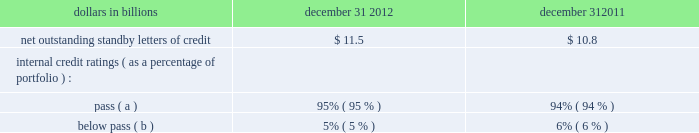Table 153 : net outstanding standby letters of credit dollars in billions december 31 december 31 .
( a ) indicates that expected risk of loss is currently low .
( b ) indicates a higher degree of risk of default .
If the customer fails to meet its financial or performance obligation to the third party under the terms of the contract or there is a need to support a remarketing program , then upon the request of the guaranteed party , subject to the terms of the letter of credit , we would be obligated to make payment to them .
The standby letters of credit and risk participations in standby letters of credit and bankers 2019 acceptances outstanding on december 31 , 2012 had terms ranging from less than 1 year to 7 years .
The aggregate maximum amount of future payments pnc could be required to make under outstanding standby letters of credit and risk participations in standby letters of credit and bankers 2019 acceptances was $ 14.7 billion at december 31 , 2012 , of which $ 7.5 billion support remarketing programs .
As of december 31 , 2012 , assets of $ 1.8 billion secured certain specifically identified standby letters of credit .
Recourse provisions from third parties of $ 3.2 billion were also available for this purpose as of december 31 , 2012 .
In addition , a portion of the remaining standby letters of credit and letter of credit risk participations issued on behalf of specific customers is also secured by collateral or guarantees that secure the customers 2019 other obligations to us .
The carrying amount of the liability for our obligations related to standby letters of credit and risk participations in standby letters of credit and bankers 2019 acceptances was $ 247 million at december 31 , 2012 .
Standby bond purchase agreements and other liquidity facilities we enter into standby bond purchase agreements to support municipal bond obligations .
At december 31 , 2012 , the aggregate of our commitments under these facilities was $ 587 million .
We also enter into certain other liquidity facilities to support individual pools of receivables acquired by commercial paper conduits .
At december 31 , 2012 , our total commitments under these facilities were $ 145 million .
Indemnifications we are a party to numerous acquisition or divestiture agreements under which we have purchased or sold , or agreed to purchase or sell , various types of assets .
These agreements can cover the purchase or sale of : 2022 entire businesses , 2022 loan portfolios , 2022 branch banks , 2022 partial interests in companies , or 2022 other types of assets .
These agreements generally include indemnification provisions under which we indemnify the third parties to these agreements against a variety of risks to the indemnified parties as a result of the transaction in question .
When pnc is the seller , the indemnification provisions will generally also provide the buyer with protection relating to the quality of the assets we are selling and the extent of any liabilities being assumed by the buyer .
Due to the nature of these indemnification provisions , we cannot quantify the total potential exposure to us resulting from them .
We provide indemnification in connection with securities offering transactions in which we are involved .
When we are the issuer of the securities , we provide indemnification to the underwriters or placement agents analogous to the indemnification provided to the purchasers of businesses from us , as described above .
When we are an underwriter or placement agent , we provide a limited indemnification to the issuer related to our actions in connection with the offering and , if there are other underwriters , indemnification to the other underwriters intended to result in an appropriate sharing of the risk of participating in the offering .
Due to the nature of these indemnification provisions , we cannot quantify the total potential exposure to us resulting from them .
In the ordinary course of business , we enter into certain types of agreements that include provisions for indemnifying third parties .
We also enter into certain types of agreements , including leases , assignments of leases , and subleases , in which we agree to indemnify third parties for acts by our agents , assignees and/or sublessees , and employees .
We also enter into contracts for the delivery of technology service in which we indemnify the other party against claims of patent and copyright infringement by third parties .
Due to the nature of these indemnification provisions , we cannot calculate our aggregate potential exposure under them .
In the ordinary course of business , we enter into contracts with third parties under which the third parties provide services on behalf of pnc .
In many of these contracts , we agree to indemnify the third party service provider under certain circumstances .
The terms of the indemnity vary from contract to contract and the amount of the indemnification liability , if any , cannot be determined .
We are a general or limited partner in certain asset management and investment limited partnerships , many of which contain indemnification provisions that would require us to make payments in excess of our remaining unfunded commitments .
While in certain of these partnerships the maximum liability to us is limited to the sum of our unfunded commitments and partnership distributions received by us , in the others the indemnification liability is unlimited .
As a result , we cannot determine our aggregate potential exposure for these indemnifications .
The pnc financial services group , inc .
2013 form 10-k 227 .
What percentage of the aggregate maximum amount of future payments pnc could be required to make under outstanding standby letters of credit and risk participations in standby letters of credit and bankers 2019 acceptances was attributable to support remarketing programs? 
Computations: (7.5 / 14.7)
Answer: 0.5102. 